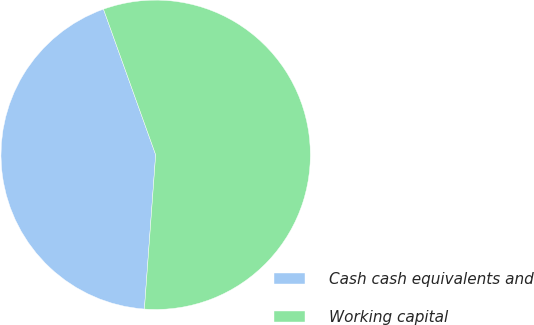<chart> <loc_0><loc_0><loc_500><loc_500><pie_chart><fcel>Cash cash equivalents and<fcel>Working capital<nl><fcel>43.36%<fcel>56.64%<nl></chart> 